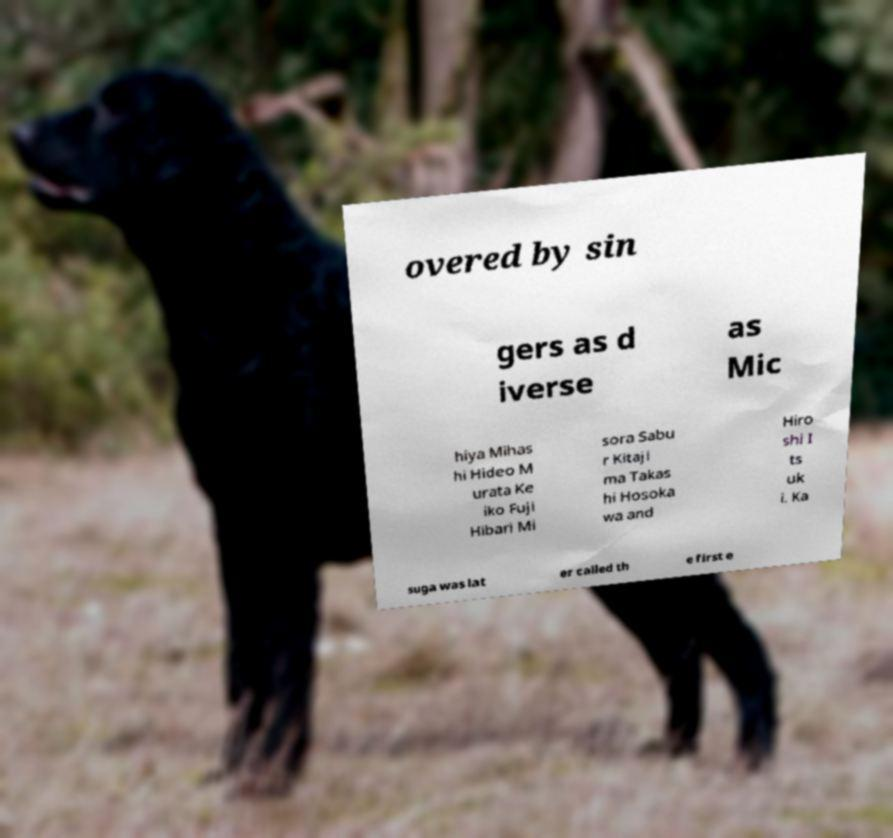Could you extract and type out the text from this image? overed by sin gers as d iverse as Mic hiya Mihas hi Hideo M urata Ke iko Fuji Hibari Mi sora Sabu r Kitaji ma Takas hi Hosoka wa and Hiro shi I ts uk i. Ka suga was lat er called th e first e 